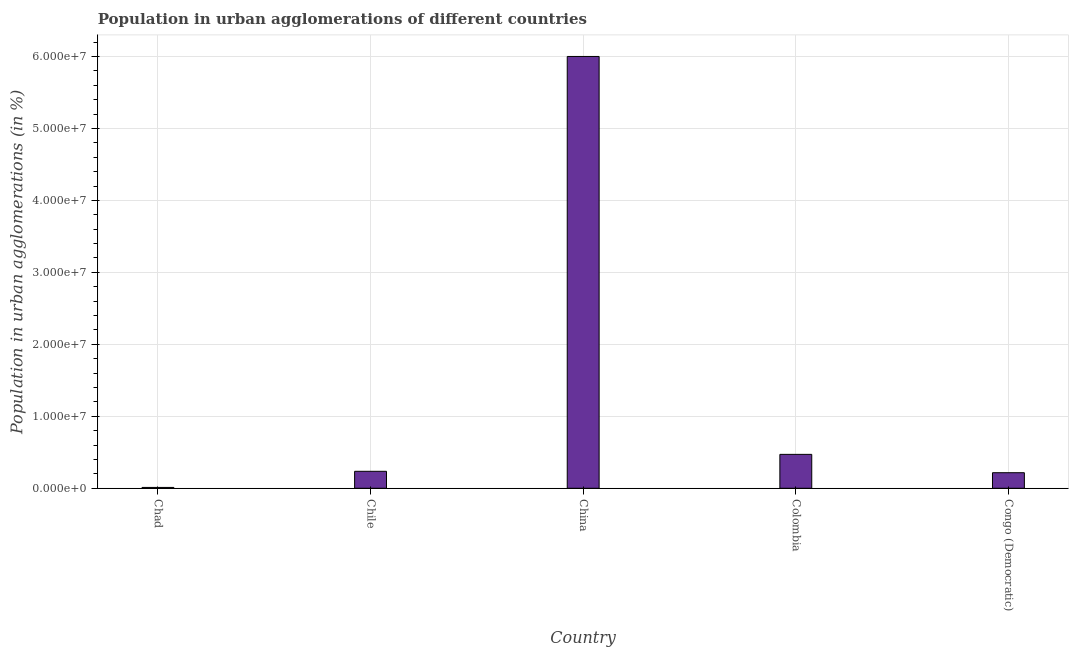Does the graph contain any zero values?
Your answer should be very brief. No. Does the graph contain grids?
Offer a very short reply. Yes. What is the title of the graph?
Your response must be concise. Population in urban agglomerations of different countries. What is the label or title of the X-axis?
Offer a terse response. Country. What is the label or title of the Y-axis?
Provide a succinct answer. Population in urban agglomerations (in %). What is the population in urban agglomerations in Colombia?
Offer a terse response. 4.71e+06. Across all countries, what is the maximum population in urban agglomerations?
Provide a succinct answer. 6.00e+07. Across all countries, what is the minimum population in urban agglomerations?
Keep it short and to the point. 1.17e+05. In which country was the population in urban agglomerations maximum?
Offer a terse response. China. In which country was the population in urban agglomerations minimum?
Your answer should be compact. Chad. What is the sum of the population in urban agglomerations?
Give a very brief answer. 6.94e+07. What is the difference between the population in urban agglomerations in Chile and Congo (Democratic)?
Offer a very short reply. 1.97e+05. What is the average population in urban agglomerations per country?
Your answer should be very brief. 1.39e+07. What is the median population in urban agglomerations?
Offer a very short reply. 2.36e+06. In how many countries, is the population in urban agglomerations greater than 52000000 %?
Offer a terse response. 1. What is the ratio of the population in urban agglomerations in Chad to that in Congo (Democratic)?
Ensure brevity in your answer.  0.05. Is the difference between the population in urban agglomerations in Chile and China greater than the difference between any two countries?
Ensure brevity in your answer.  No. What is the difference between the highest and the second highest population in urban agglomerations?
Offer a very short reply. 5.53e+07. What is the difference between the highest and the lowest population in urban agglomerations?
Give a very brief answer. 5.99e+07. In how many countries, is the population in urban agglomerations greater than the average population in urban agglomerations taken over all countries?
Your answer should be very brief. 1. Are all the bars in the graph horizontal?
Offer a terse response. No. How many countries are there in the graph?
Your answer should be compact. 5. Are the values on the major ticks of Y-axis written in scientific E-notation?
Offer a very short reply. Yes. What is the Population in urban agglomerations (in %) of Chad?
Make the answer very short. 1.17e+05. What is the Population in urban agglomerations (in %) in Chile?
Your answer should be very brief. 2.36e+06. What is the Population in urban agglomerations (in %) of China?
Give a very brief answer. 6.00e+07. What is the Population in urban agglomerations (in %) in Colombia?
Your answer should be compact. 4.71e+06. What is the Population in urban agglomerations (in %) of Congo (Democratic)?
Offer a terse response. 2.16e+06. What is the difference between the Population in urban agglomerations (in %) in Chad and Chile?
Give a very brief answer. -2.24e+06. What is the difference between the Population in urban agglomerations (in %) in Chad and China?
Your answer should be very brief. -5.99e+07. What is the difference between the Population in urban agglomerations (in %) in Chad and Colombia?
Your answer should be very brief. -4.59e+06. What is the difference between the Population in urban agglomerations (in %) in Chad and Congo (Democratic)?
Ensure brevity in your answer.  -2.05e+06. What is the difference between the Population in urban agglomerations (in %) in Chile and China?
Provide a succinct answer. -5.76e+07. What is the difference between the Population in urban agglomerations (in %) in Chile and Colombia?
Offer a very short reply. -2.35e+06. What is the difference between the Population in urban agglomerations (in %) in Chile and Congo (Democratic)?
Offer a very short reply. 1.97e+05. What is the difference between the Population in urban agglomerations (in %) in China and Colombia?
Offer a terse response. 5.53e+07. What is the difference between the Population in urban agglomerations (in %) in China and Congo (Democratic)?
Offer a very short reply. 5.78e+07. What is the difference between the Population in urban agglomerations (in %) in Colombia and Congo (Democratic)?
Your answer should be compact. 2.55e+06. What is the ratio of the Population in urban agglomerations (in %) in Chad to that in China?
Make the answer very short. 0. What is the ratio of the Population in urban agglomerations (in %) in Chad to that in Colombia?
Offer a very short reply. 0.03. What is the ratio of the Population in urban agglomerations (in %) in Chad to that in Congo (Democratic)?
Your response must be concise. 0.05. What is the ratio of the Population in urban agglomerations (in %) in Chile to that in China?
Ensure brevity in your answer.  0.04. What is the ratio of the Population in urban agglomerations (in %) in Chile to that in Colombia?
Your answer should be compact. 0.5. What is the ratio of the Population in urban agglomerations (in %) in Chile to that in Congo (Democratic)?
Keep it short and to the point. 1.09. What is the ratio of the Population in urban agglomerations (in %) in China to that in Colombia?
Offer a very short reply. 12.73. What is the ratio of the Population in urban agglomerations (in %) in China to that in Congo (Democratic)?
Ensure brevity in your answer.  27.74. What is the ratio of the Population in urban agglomerations (in %) in Colombia to that in Congo (Democratic)?
Keep it short and to the point. 2.18. 